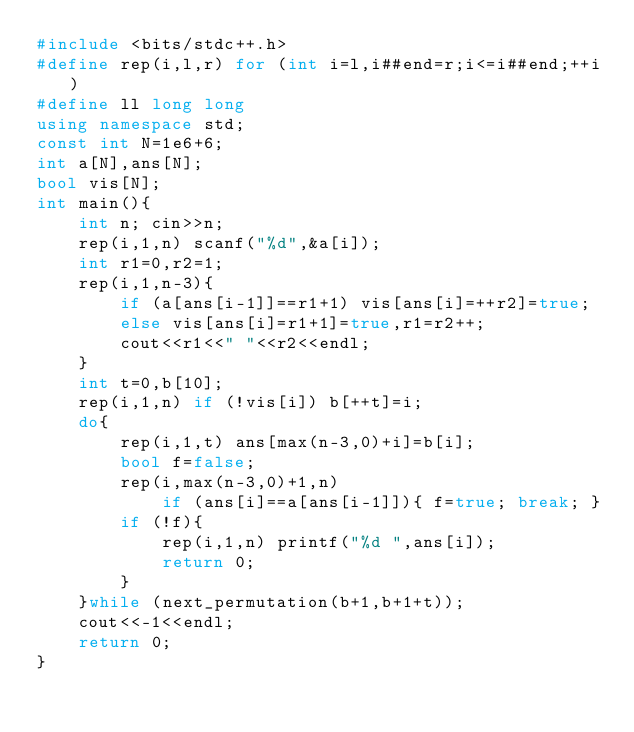Convert code to text. <code><loc_0><loc_0><loc_500><loc_500><_C++_>#include <bits/stdc++.h>
#define rep(i,l,r) for (int i=l,i##end=r;i<=i##end;++i)
#define ll long long
using namespace std;
const int N=1e6+6;
int a[N],ans[N];
bool vis[N];
int main(){
    int n; cin>>n;
    rep(i,1,n) scanf("%d",&a[i]);
    int r1=0,r2=1;
    rep(i,1,n-3){
        if (a[ans[i-1]]==r1+1) vis[ans[i]=++r2]=true;
        else vis[ans[i]=r1+1]=true,r1=r2++;
        cout<<r1<<" "<<r2<<endl;
    }
    int t=0,b[10];
    rep(i,1,n) if (!vis[i]) b[++t]=i;
    do{
        rep(i,1,t) ans[max(n-3,0)+i]=b[i];
        bool f=false;
        rep(i,max(n-3,0)+1,n)
            if (ans[i]==a[ans[i-1]]){ f=true; break; }
        if (!f){
            rep(i,1,n) printf("%d ",ans[i]);
            return 0;
        }
    }while (next_permutation(b+1,b+1+t));
    cout<<-1<<endl;
    return 0;
}
</code> 